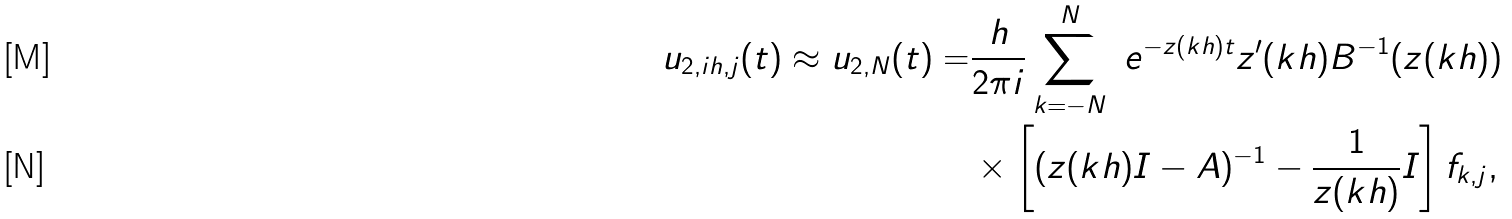<formula> <loc_0><loc_0><loc_500><loc_500>u _ { 2 , i h , j } ( t ) \approx u _ { 2 , N } ( t ) = & \frac { h } { 2 \pi i } \sum _ { k = - N } ^ { N } \ e ^ { - z ( k h ) t } z ^ { \prime } ( k h ) B ^ { - 1 } ( z ( k h ) ) \\ & \times \left [ ( z ( k h ) I - A ) ^ { - 1 } - \frac { 1 } { z ( k h ) } I \right ] f _ { k , j } ,</formula> 